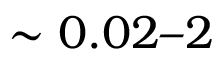<formula> <loc_0><loc_0><loc_500><loc_500>\sim 0 . 0 2 2</formula> 